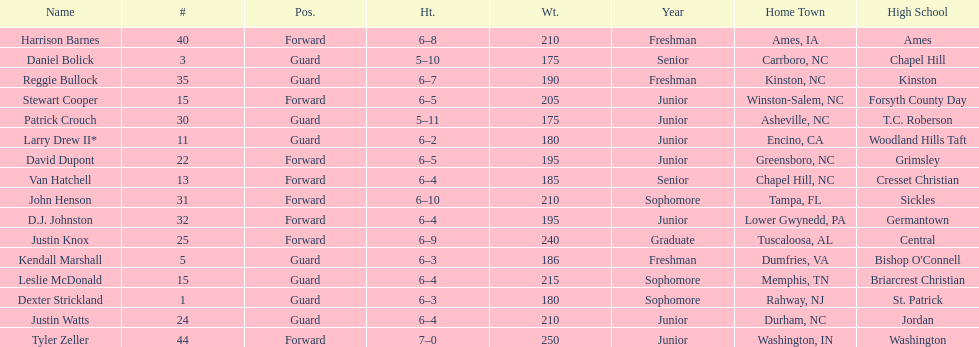How many players are not a junior? 9. 